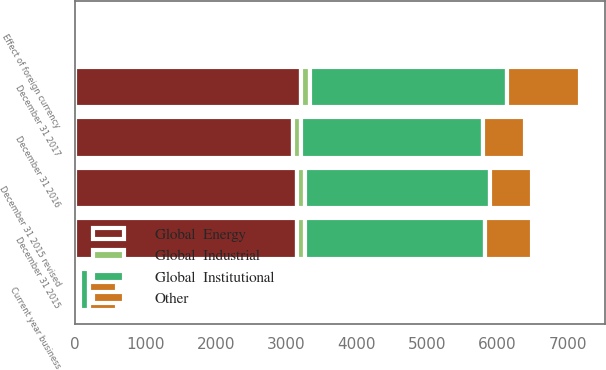Convert chart to OTSL. <chart><loc_0><loc_0><loc_500><loc_500><stacked_bar_chart><ecel><fcel>December 31 2015<fcel>December 31 2015 revised<fcel>Effect of foreign currency<fcel>December 31 2016<fcel>Current year business<fcel>December 31 2017<nl><fcel>Global  Institutional<fcel>2560.8<fcel>2623.5<fcel>45.5<fcel>2585<fcel>123.4<fcel>2797<nl><fcel>Other<fcel>662.7<fcel>600<fcel>11.8<fcel>590.7<fcel>403.7<fcel>1027<nl><fcel>Global  Energy<fcel>3151.5<fcel>3151.5<fcel>55.7<fcel>3093.6<fcel>8.1<fcel>3203.7<nl><fcel>Global  Industrial<fcel>115.8<fcel>115.8<fcel>2.1<fcel>113.7<fcel>63.9<fcel>139.4<nl></chart> 